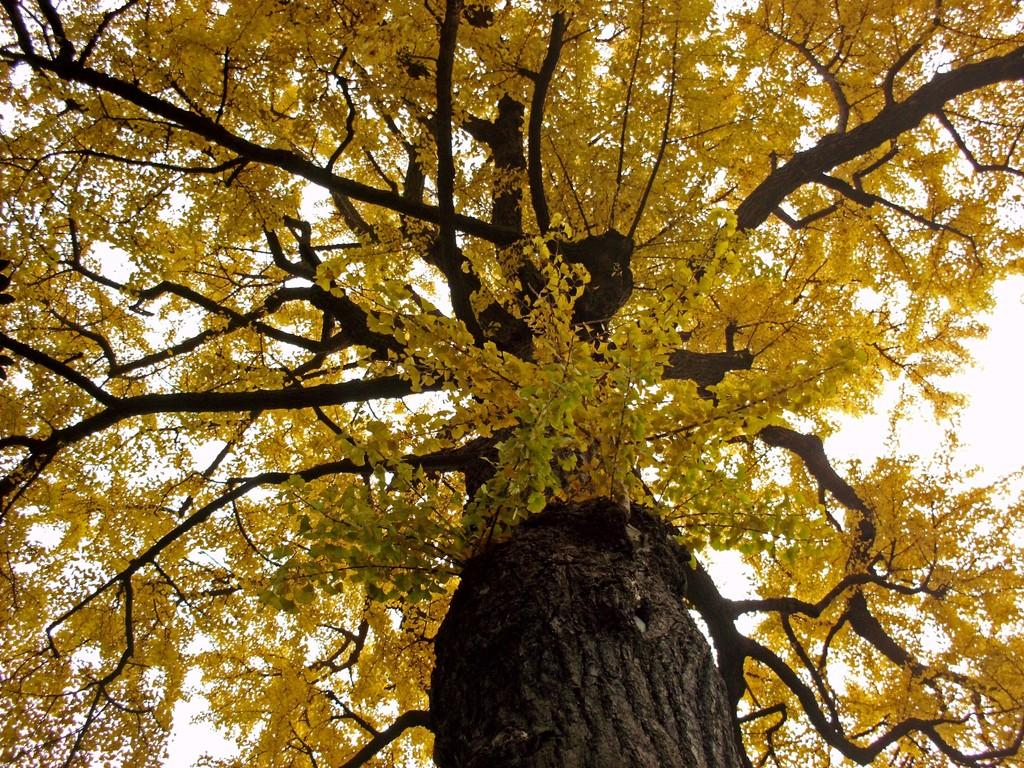What is the main subject of the image? The main subject of the image is a yellow color tree. Can you describe the tree in the image? The tree is yellow in color and is located in the center of the image. What type of lamp is hanging from the tree in the image? There is no lamp present in the image; it only features a yellow color tree. What is the condition of the tree in the image? The condition of the tree cannot be determined from the image alone, as it only shows the tree's color and location. 